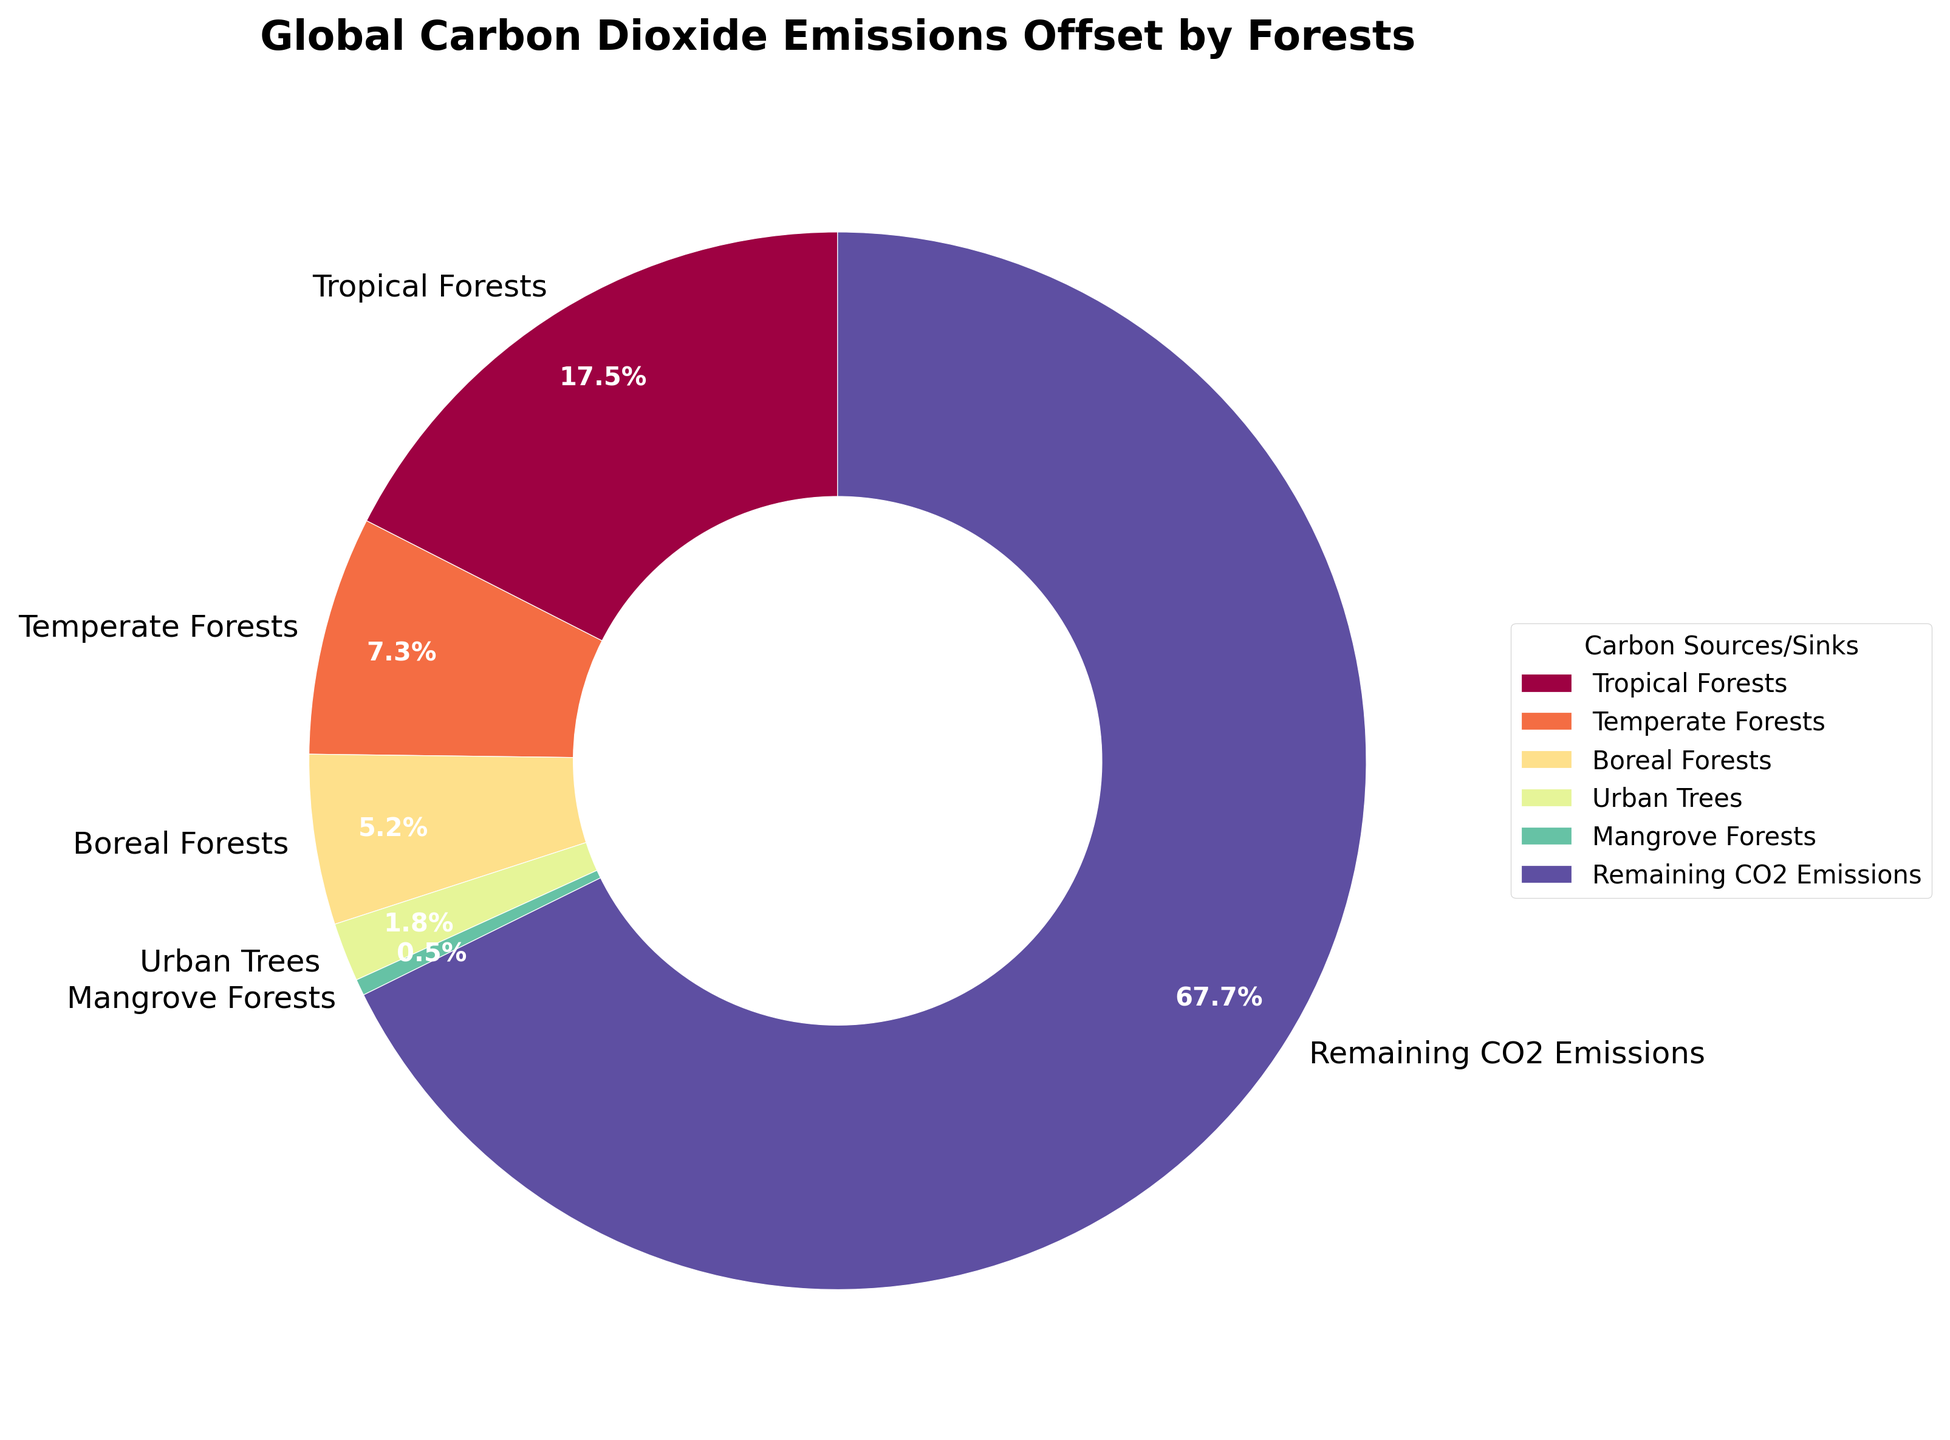What's the combined percentage of CO2 emissions offset by Tropical and Temperate Forests? To find the combined percentage, sum the percentages of Tropical Forests and Temperate Forests. That is 17.5% + 7.3% = 24.8%.
Answer: 24.8% Which type of forest offsets more CO2 emissions, Boreal Forests or Urban Trees? Compare the percentages of Boreal Forests and Urban Trees. Boreal Forests offset 5.2% of CO2 emissions, while Urban Trees offset 1.8%.
Answer: Boreal Forests What percentage of carbon dioxide emissions is offset by Mangrove Forests? Simply refer to the pie chart's label for Mangrove Forests, which indicates they offset 0.5% of CO2 emissions.
Answer: 0.5% Are the CO2 emissions offset by Urban Trees greater than those offset by Mangrove Forests? Compare the percentages of Urban Trees and Mangrove Forests. Urban Trees offset 1.8% of CO2 emissions, and Mangrove Forests offset 0.5%, so Urban Trees offset more.
Answer: Yes What fraction of the total CO2 emissions is offset by Boreal and Temperate Forests together? Sum the percentages of Boreal and Temperate Forests, which is 5.2% + 7.3% = 12.5%. Then, express 12.5% as a fraction.
Answer: 12.5% Which category offsets the least amount of CO2 emissions, and what is its percentage? The smallest percentage on the pie chart corresponds to Mangrove Forests, which offset 0.5% of CO2 emissions.
Answer: Mangrove Forests, 0.5% How much more CO2 emissions are offset by Tropical Forests than Urban Trees? Subtract the percentage of Urban Trees from the percentage of Tropical Forests: 17.5% - 1.8% = 15.7%.
Answer: 15.7% Arrange the categories in descending order of their CO2 emissions offset percentages. Order the categories from largest to smallest percentages: Tropical Forests (17.5%), Temperate Forests (7.3%), Boreal Forests (5.2%), Urban Trees (1.8%), Mangrove Forests (0.5%).
Answer: Tropical Forests, Temperate Forests, Boreal Forests, Urban Trees, Mangrove Forests How does the combined percentage of CO2 emissions offset by all forests compare to the remaining CO2 emissions? First, sum the percentages of all forest types: 17.5% + 7.3% + 5.2% + 1.8% + 0.5% = 32.3%. Then compare this with the remaining CO2 emissions percentage, which is 67.7%. The combined percentage of forests is less than the remaining CO2 emissions.
Answer: Less What is the difference in CO2 emissions offset between the highest-ranking and lowest-ranking forest types? Find the difference between the largest and smallest percentages: 17.5% (Tropical Forests) - 0.5% (Mangrove Forests) = 17.0%.
Answer: 17.0% 